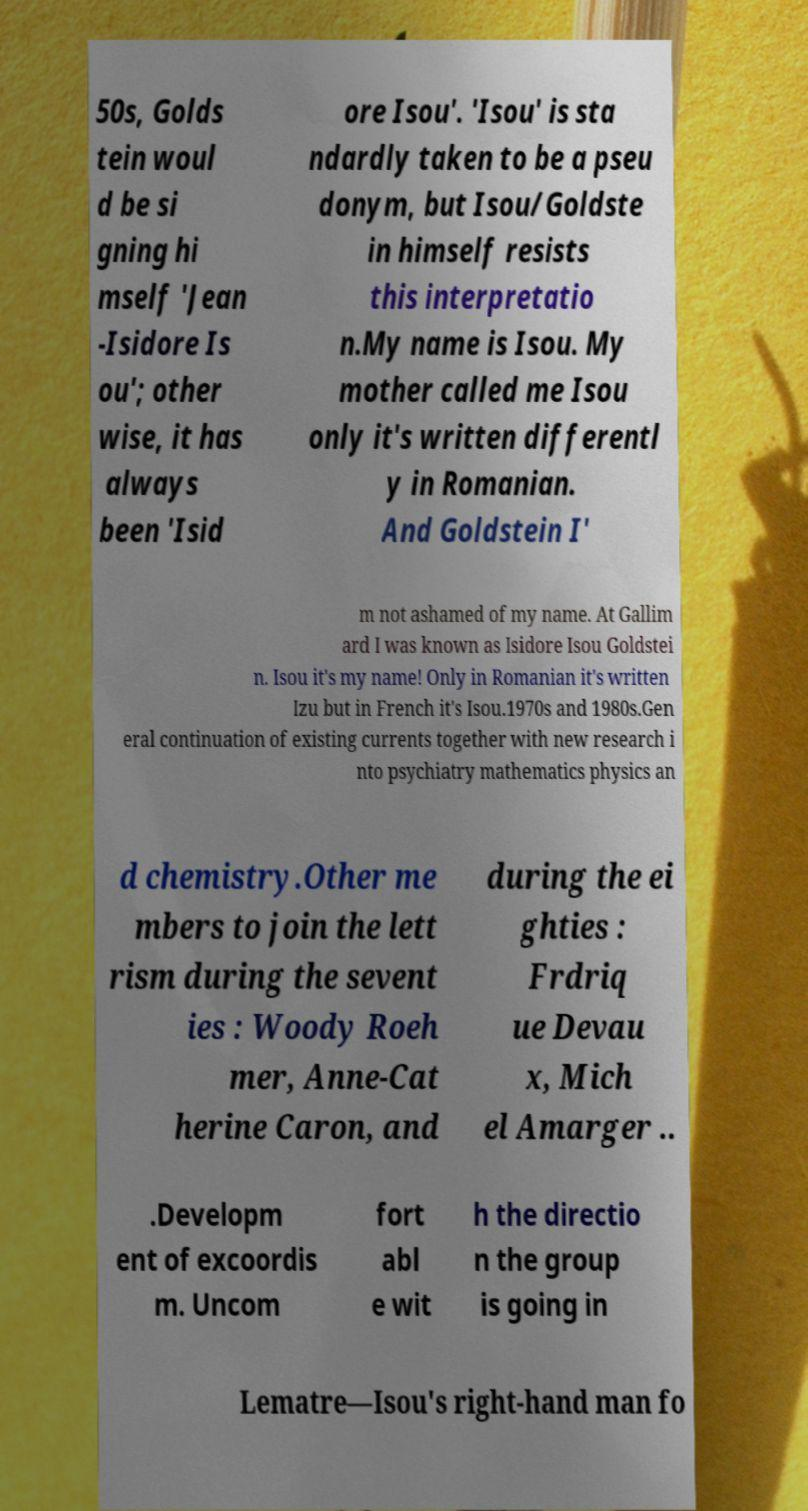I need the written content from this picture converted into text. Can you do that? 50s, Golds tein woul d be si gning hi mself 'Jean -Isidore Is ou'; other wise, it has always been 'Isid ore Isou'. 'Isou' is sta ndardly taken to be a pseu donym, but Isou/Goldste in himself resists this interpretatio n.My name is Isou. My mother called me Isou only it's written differentl y in Romanian. And Goldstein I' m not ashamed of my name. At Gallim ard I was known as Isidore Isou Goldstei n. Isou it's my name! Only in Romanian it's written Izu but in French it's Isou.1970s and 1980s.Gen eral continuation of existing currents together with new research i nto psychiatry mathematics physics an d chemistry.Other me mbers to join the lett rism during the sevent ies : Woody Roeh mer, Anne-Cat herine Caron, and during the ei ghties : Frdriq ue Devau x, Mich el Amarger .. .Developm ent of excoordis m. Uncom fort abl e wit h the directio n the group is going in Lematre—Isou's right-hand man fo 